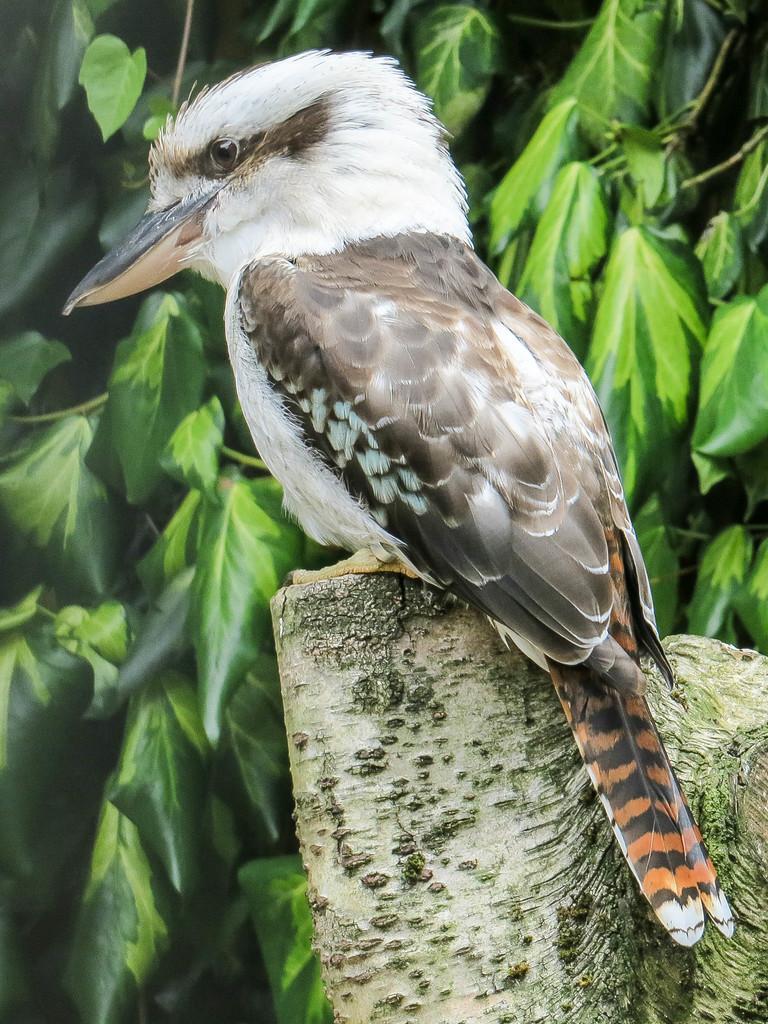Can you describe this image briefly? In this image we can see a bird which is in white and brown color which is on branch of a tree and in the background of the image there are some leaves. 